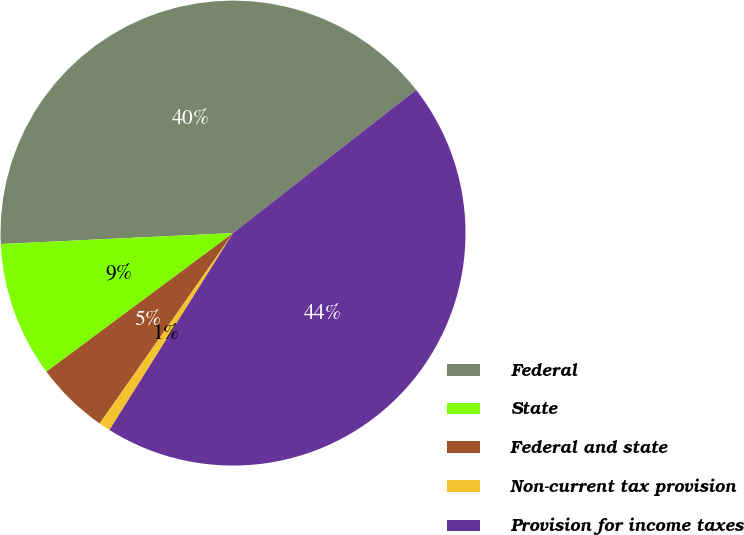Convert chart to OTSL. <chart><loc_0><loc_0><loc_500><loc_500><pie_chart><fcel>Federal<fcel>State<fcel>Federal and state<fcel>Non-current tax provision<fcel>Provision for income taxes<nl><fcel>40.18%<fcel>9.42%<fcel>5.11%<fcel>0.8%<fcel>44.49%<nl></chart> 